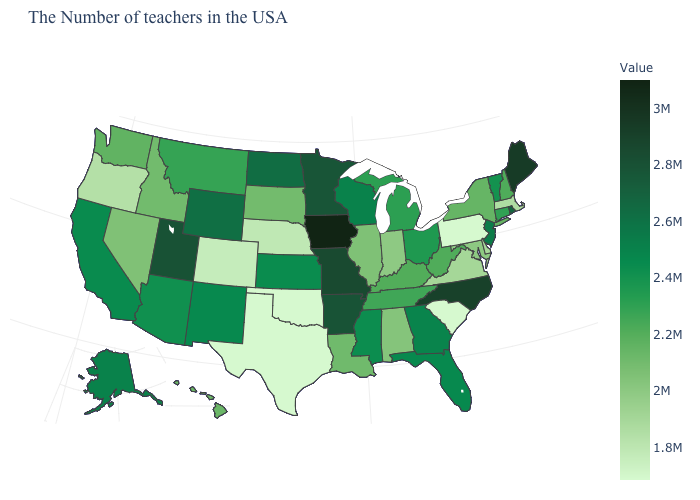Is the legend a continuous bar?
Quick response, please. Yes. Is the legend a continuous bar?
Be succinct. Yes. Does North Carolina have the highest value in the South?
Short answer required. Yes. Does Massachusetts have the lowest value in the Northeast?
Keep it brief. No. Among the states that border Delaware , which have the highest value?
Answer briefly. New Jersey. 